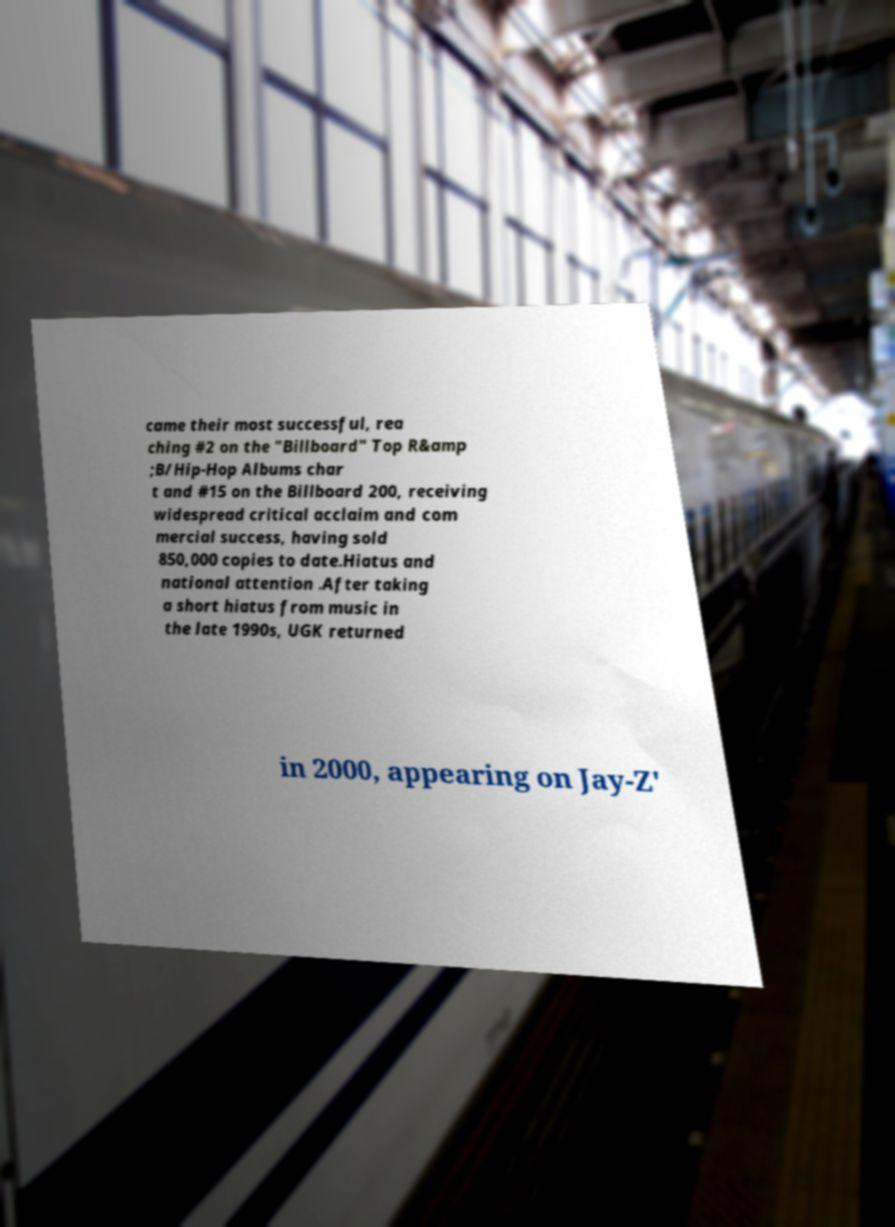For documentation purposes, I need the text within this image transcribed. Could you provide that? came their most successful, rea ching #2 on the "Billboard" Top R&amp ;B/Hip-Hop Albums char t and #15 on the Billboard 200, receiving widespread critical acclaim and com mercial success, having sold 850,000 copies to date.Hiatus and national attention .After taking a short hiatus from music in the late 1990s, UGK returned in 2000, appearing on Jay-Z' 